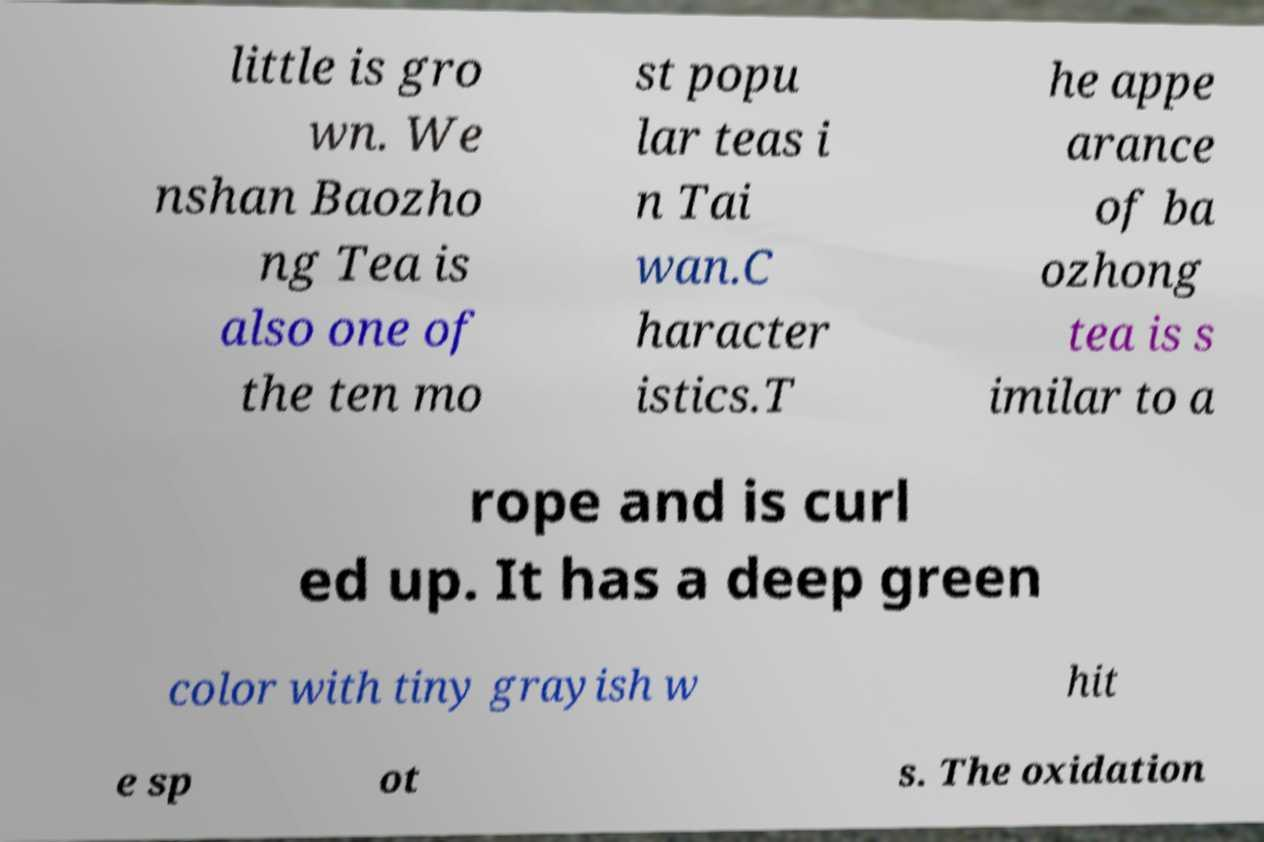Could you extract and type out the text from this image? little is gro wn. We nshan Baozho ng Tea is also one of the ten mo st popu lar teas i n Tai wan.C haracter istics.T he appe arance of ba ozhong tea is s imilar to a rope and is curl ed up. It has a deep green color with tiny grayish w hit e sp ot s. The oxidation 